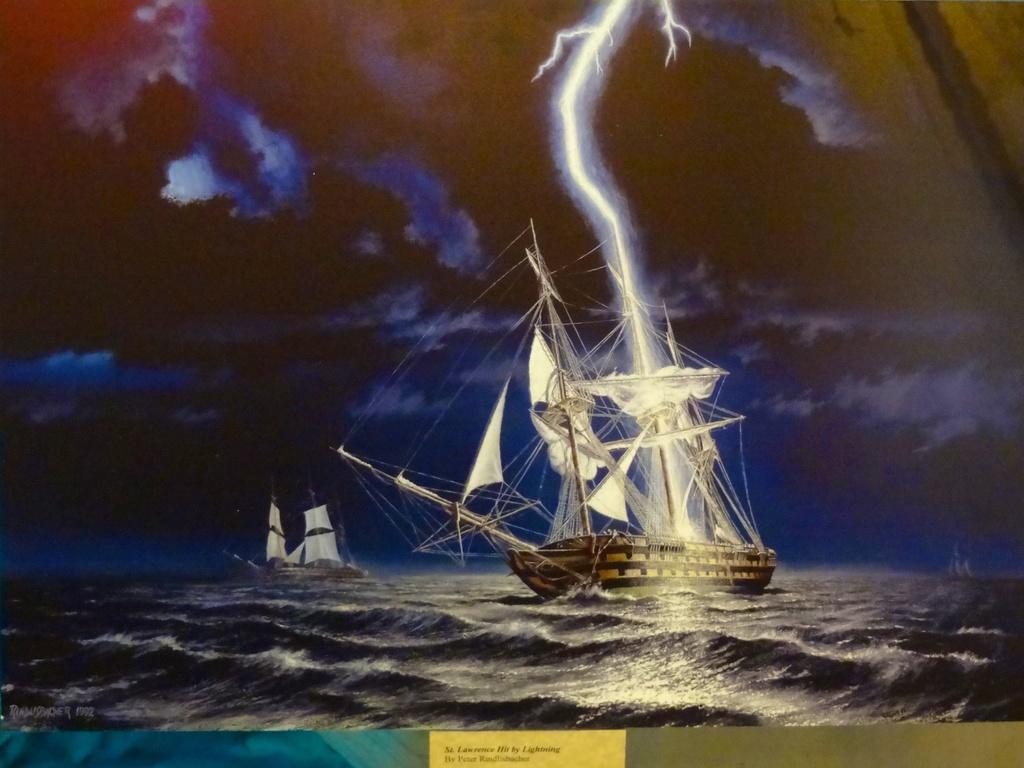How would you summarize this image in a sentence or two? In this picture it looks like the painting of ships sailing on the water. At the top we can see the dark sky with lightning thunder. 